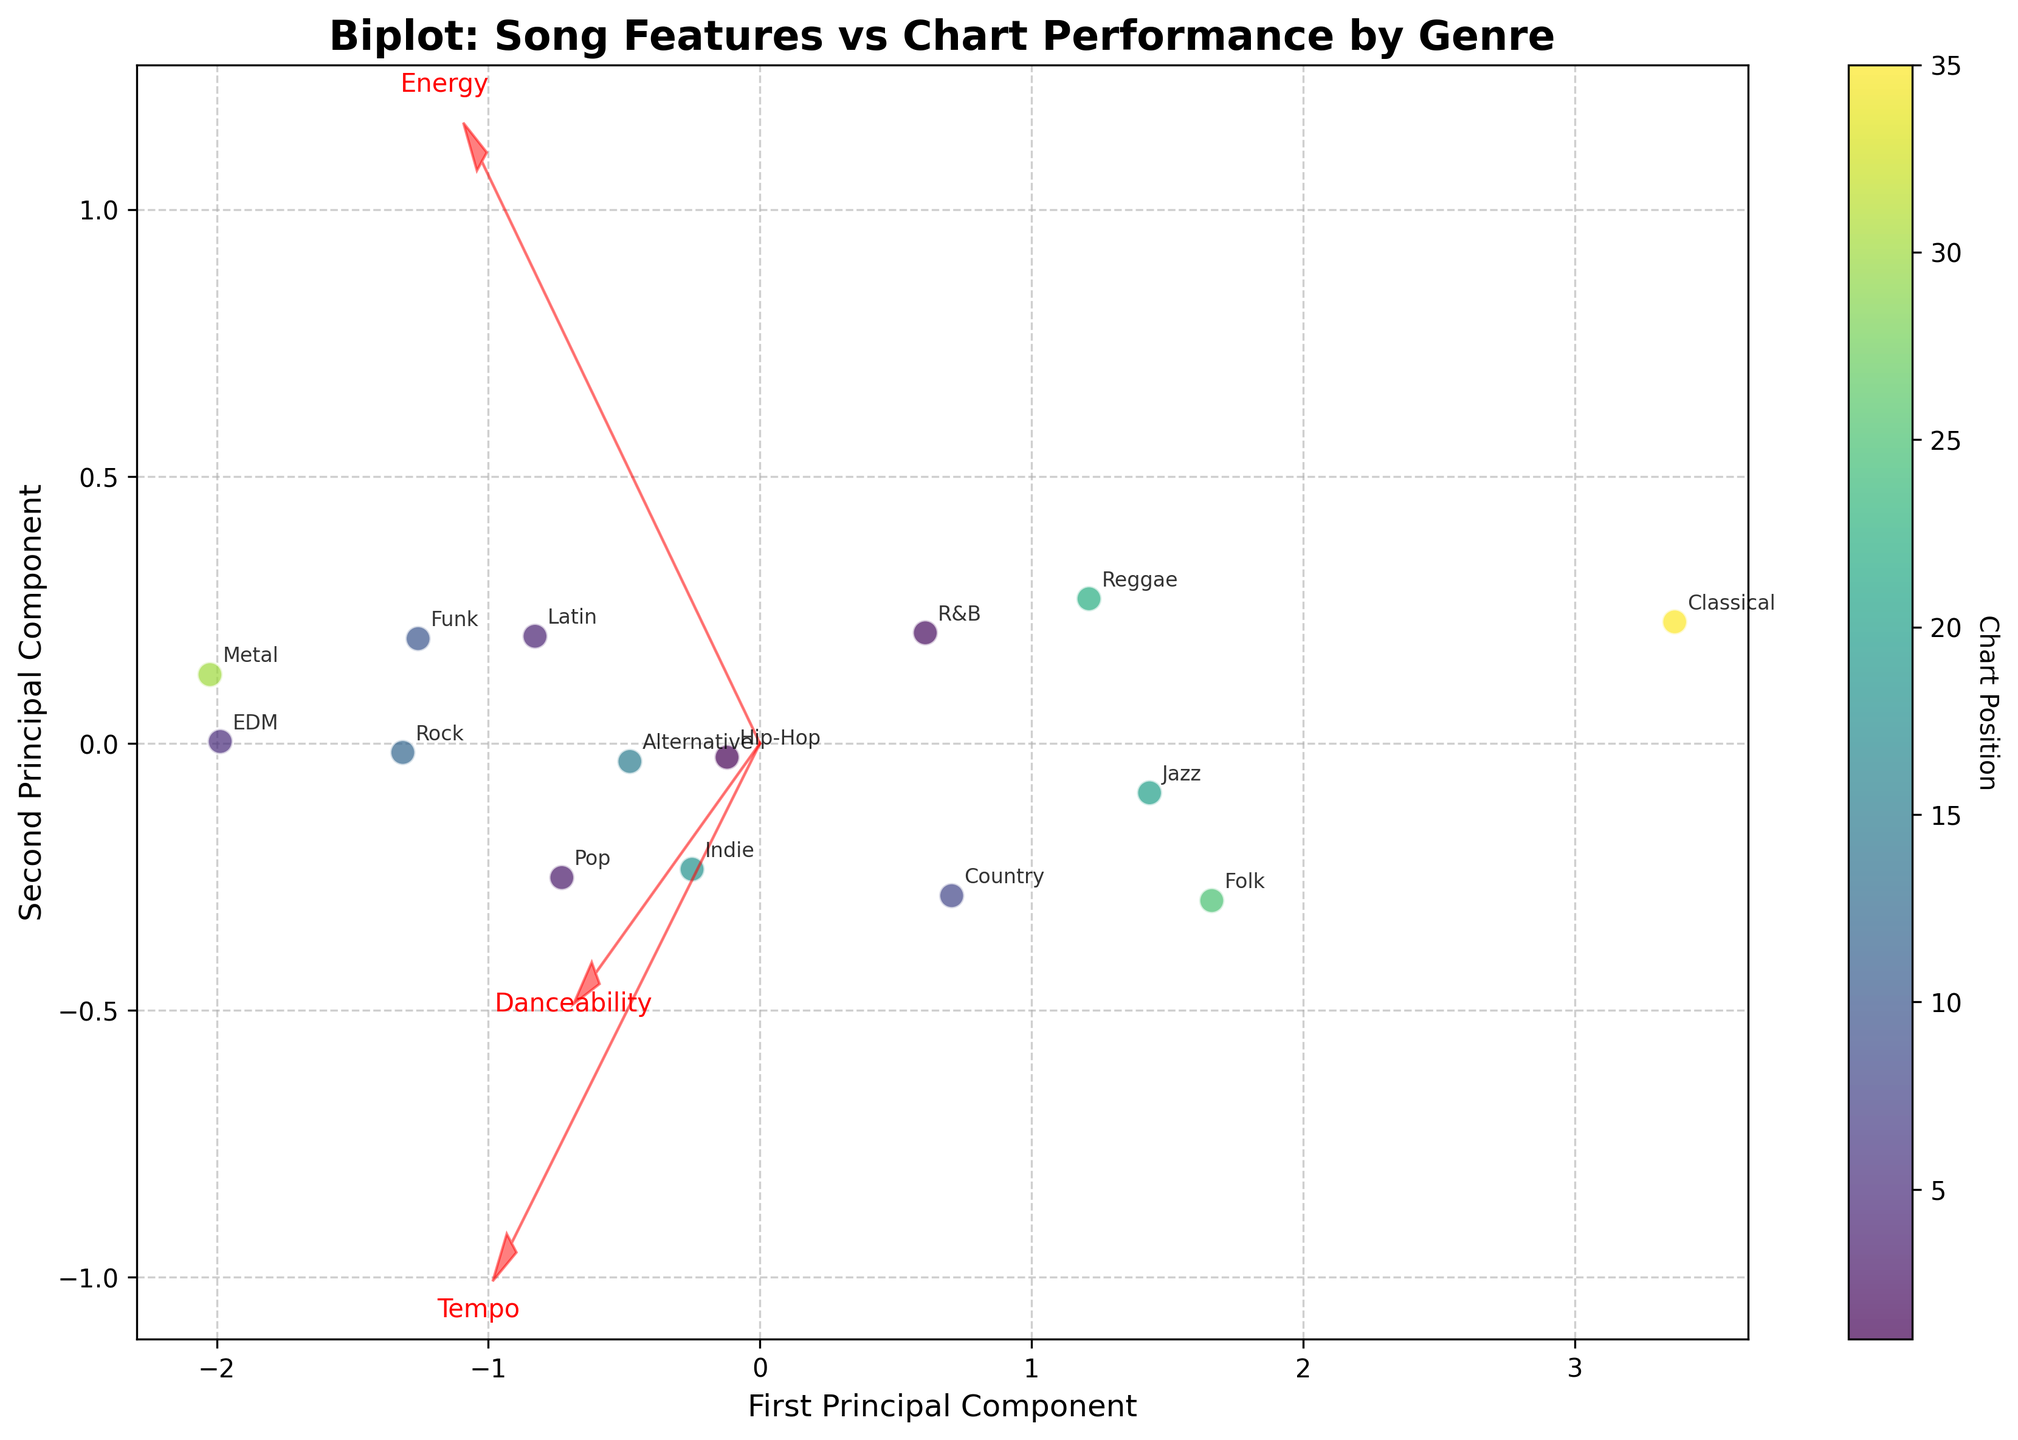How many genres are represented in the biplot? Count the number of unique genre labels in the figure. Each genre corresponds to one annotated point.
Answer: 15 What is the title of the figure? The title is displayed at the top of the plot.
Answer: Biplot: Song Features vs Chart Performance by Genre Which genre is closest to the feature vector labeled "Danceability"? Identify the point closest to the direction of the arrow labeled "Danceability".
Answer: EDM Does the genre 'Classical' have a high or low score on the second principal component? Observe the vertical position of the 'Classical' label. It is positioned lower on the vertical axis, indicating a low score on the second principal component.
Answer: Low Which two genres have the closest chart positions and are plotted near each other? Look for points close to each other regarding position along with their color shading that indicates chart position. In this case, 'Indie' and 'Alternative' are relatively close in the plot and their chart positions (15 and 18 respectively) are also close.
Answer: Indie and Alternative On which side of the first principal component axis do most high charted genres (lower chart position values) appear? Examine the colors of the points on either side of the first principal component axis and which side has lighter shading indicating higher charted songs.
Answer: Left side Which genre is associated with the highest energy and indicated by the direction of the feature vector and point position? Follow the arrow labeled "Energy" and identify the closest genre point.
Answer: Metal What can you infer about the relation between 'Tempo' and 'Danceability' based on the position of their vectors? Analyze the angle between the vectors for "Tempo" and "Danceability". If they point in relatively the same direction, they are positively correlated. If at an angle, it suggests a less direct relationship.
Answer: Positively correlated Is there any genre that is closely associated with both high energy and high danceability? If so, which one? Find a genre point that is positioned closely in the direction indicated by both the "Energy" and "Danceability" vectors.
Answer: EDM 